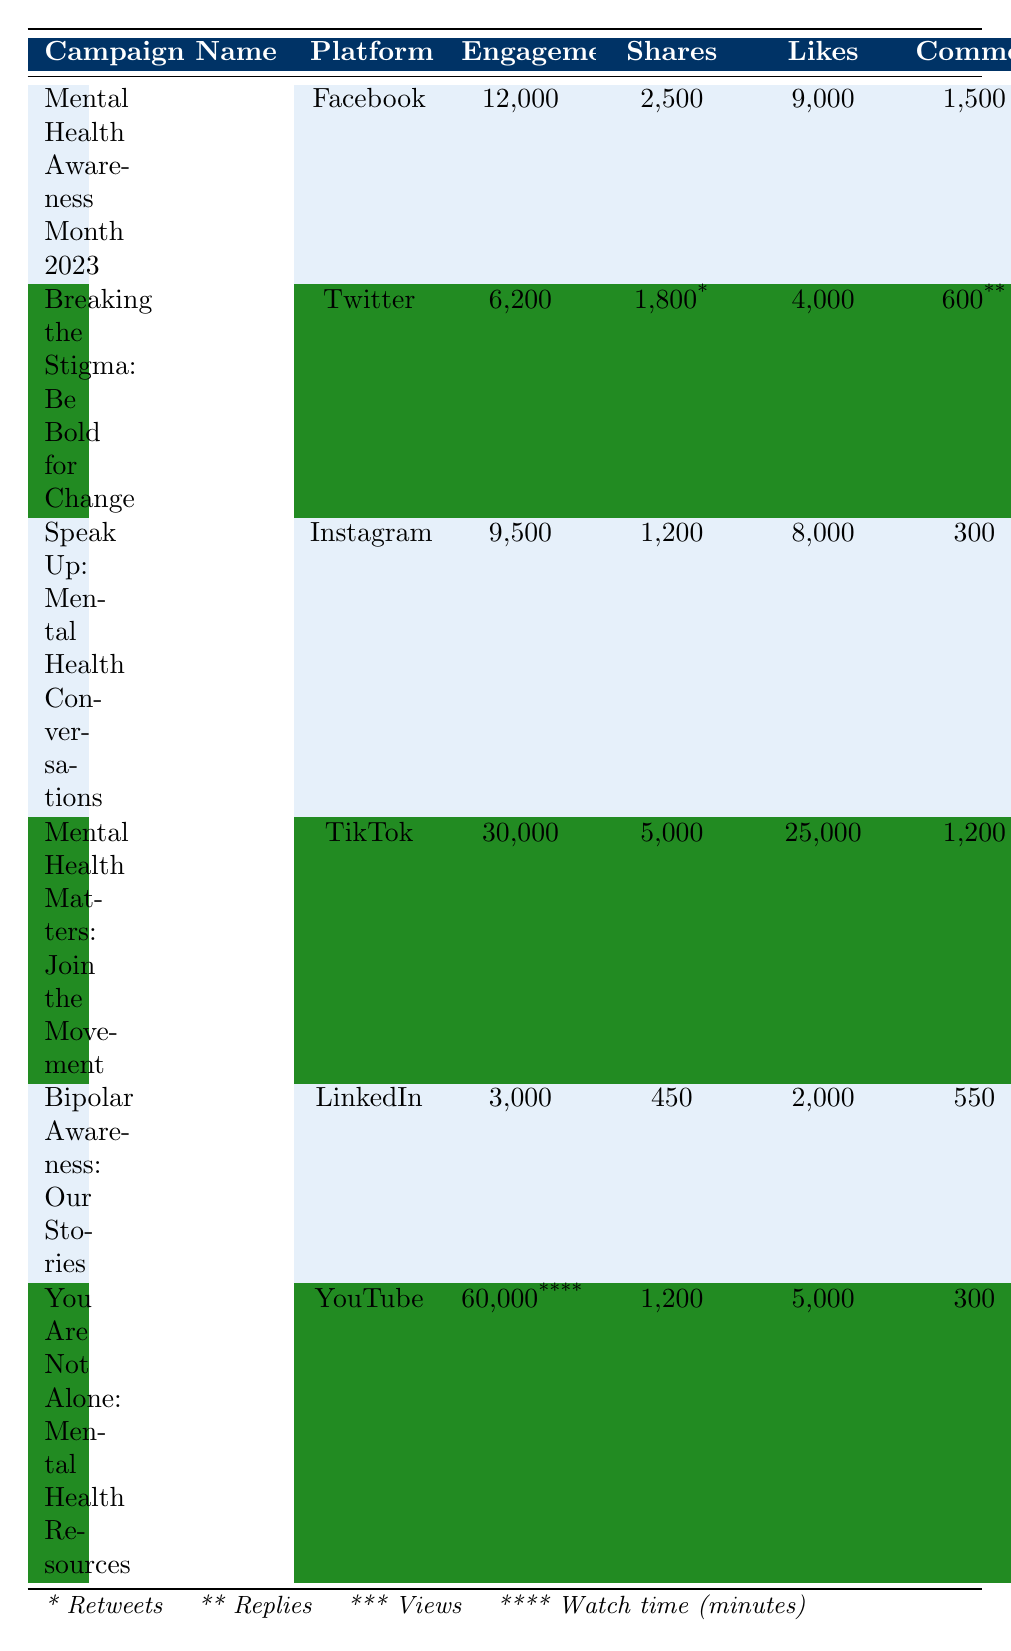What is the platform for the "Mental Health Awareness Month 2023" campaign? The table shows the campaign name "Mental Health Awareness Month 2023" listed under the "Platform" column, indicating it was conducted on Facebook.
Answer: Facebook How many likes did the "Speak Up: Mental Health Conversations" campaign receive? The table includes the campaign name "Speak Up: Mental Health Conversations" under the "Likes" column, which shows it received 8,000 likes.
Answer: 8000 Which campaign had the highest total engagements? By comparing the "Engagements" column, "You Are Not Alone: Mental Health Resources" has 60,000, which is the highest value across all campaigns.
Answer: 60000 What is the total number of shares from the "Mental Health Matters: Join the Movement" campaign? The table shows "Mental Health Matters: Join the Movement" had 5,000 shares listed under the "Shares" column.
Answer: 5000 Is the number of views for the "Mental Health Matters: Join the Movement" campaign greater than 200,000? The table indicates the views for this campaign is noted as 230,000 which is greater than 200,000. Therefore, this statement is true.
Answer: Yes What is the average number of likes for all the campaigns listed? Adding the likes: (9000 + 4000 + 8000 + 25000 + 2000 + 5000) = 50,000. There are 6 campaigns, so the average is 50,000 / 6 = 8,333.33.
Answer: 8333.33 Which platform had the most impressions in the campaigns listed? Looking at the "Impressions" column, TikTok's "Mental Health Matters: Join the Movement" showed 230,000 impressions, the highest value among all platforms.
Answer: TikTok How many total engagements did the "Breaking the Stigma: Be Bold for Change" campaign have? The total engagements for this campaign, according to the table, is directly shown as 6,200 under the "Total Engagements" column.
Answer: 6200 Did the "You Are Not Alone: Mental Health Resources" campaign gain more than 150 subscribers? The table notes that this campaign gained 100 subscribers, which is less than 150, making the statement false.
Answer: No What is the difference in post engagements between "Mental Health Awareness Month 2023" and "Bipolar Awareness: Our Stories"? The post engagements for both campaigns are: 12,000 - 3,000 = 9,000, showing the difference in post engagements.
Answer: 9000 